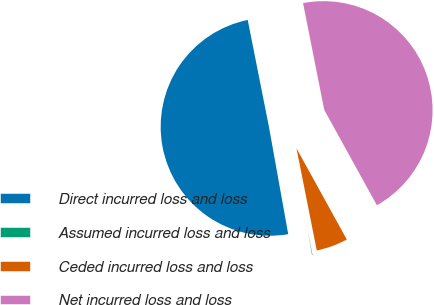Convert chart to OTSL. <chart><loc_0><loc_0><loc_500><loc_500><pie_chart><fcel>Direct incurred loss and loss<fcel>Assumed incurred loss and loss<fcel>Ceded incurred loss and loss<fcel>Net incurred loss and loss<nl><fcel>49.71%<fcel>0.29%<fcel>4.91%<fcel>45.09%<nl></chart> 